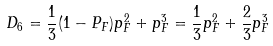Convert formula to latex. <formula><loc_0><loc_0><loc_500><loc_500>D _ { 6 } = \frac { 1 } { 3 } ( 1 - P _ { F } ) p ^ { 2 } _ { F } + p ^ { 3 } _ { F } = \frac { 1 } { 3 } p ^ { 2 } _ { F } + \frac { 2 } { 3 } p ^ { 3 } _ { F }</formula> 